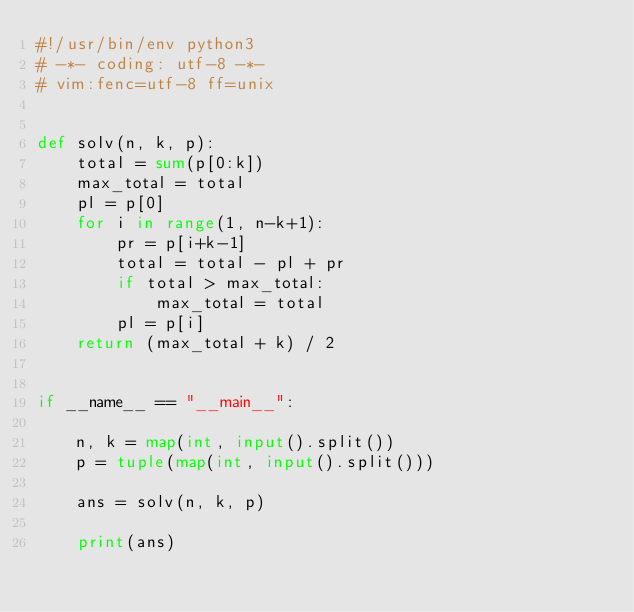<code> <loc_0><loc_0><loc_500><loc_500><_Python_>#!/usr/bin/env python3
# -*- coding: utf-8 -*-
# vim:fenc=utf-8 ff=unix


def solv(n, k, p):
    total = sum(p[0:k])
    max_total = total
    pl = p[0]
    for i in range(1, n-k+1):
        pr = p[i+k-1]
        total = total - pl + pr
        if total > max_total:
            max_total = total
        pl = p[i]
    return (max_total + k) / 2


if __name__ == "__main__":

    n, k = map(int, input().split())
    p = tuple(map(int, input().split()))

    ans = solv(n, k, p)

    print(ans)
</code> 